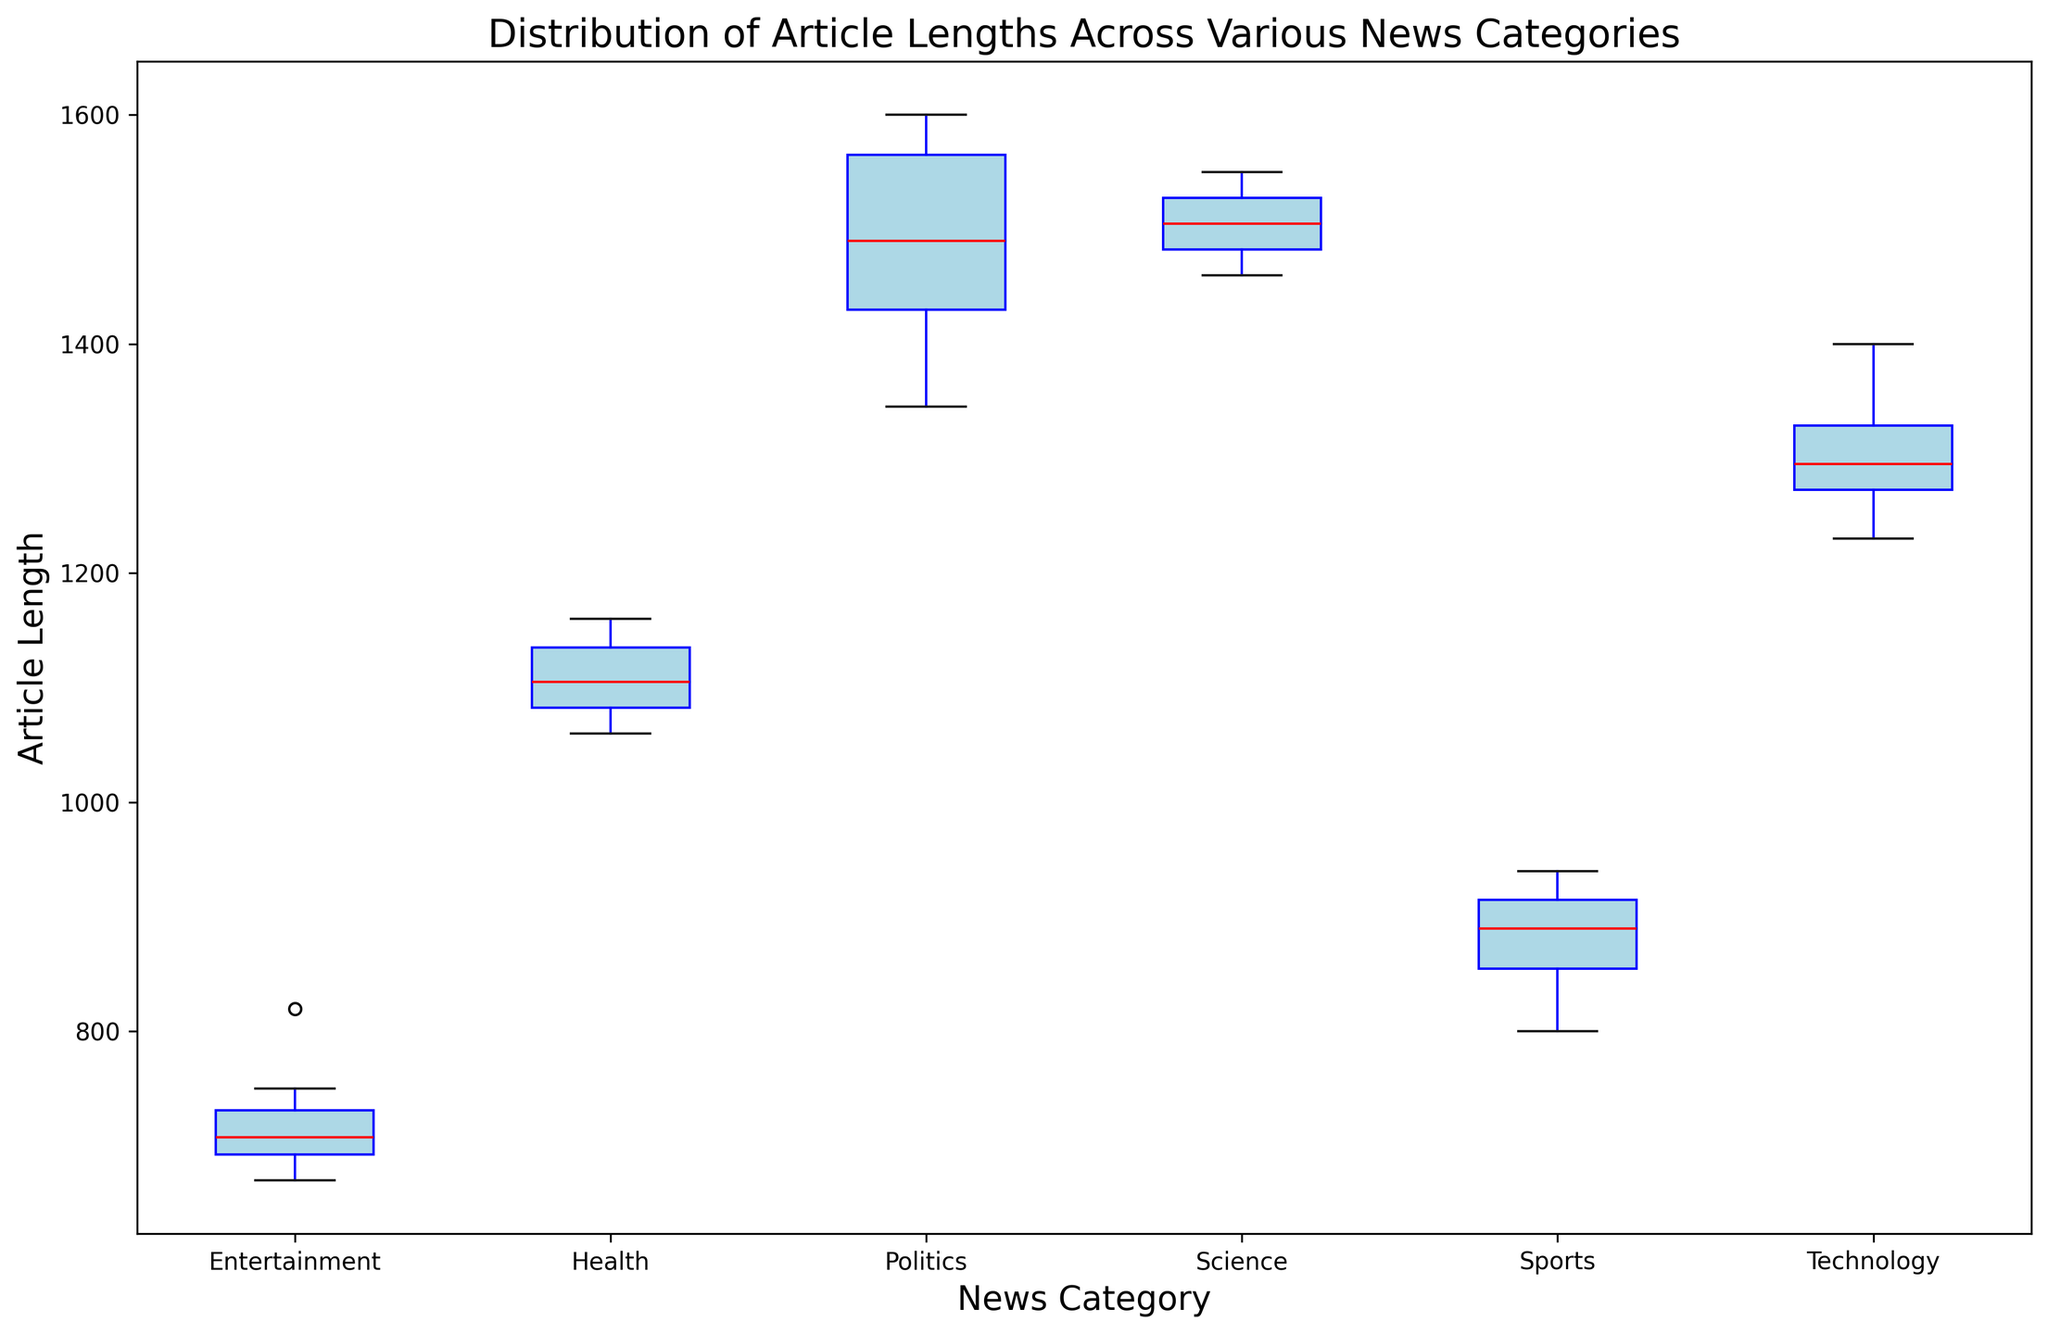What's the median article length for the 'Politics' category? The red line inside the box of the 'Politics' category represents the median. By looking at the red line within the 'Politics' box, we can determine the median length.
Answer: 1500 Which category has the smallest interquartile range (IQR) for article lengths? The IQR is represented by the width of the box in each category. By visually comparing the widths of the boxes, we can identify which one is the smallest.
Answer: Entertainment What is the range of article lengths for the 'Science' category? The range is determined by subtracting the smallest value (lower whisker) from the largest value (upper whisker) in the 'Science' box plot.
Answer: 90 How do the median article lengths of 'Technology' and 'Health' categories compare? By looking at the red median lines inside the 'Technology' and 'Health' category boxes, we can compare their positions.
Answer: Technology has a higher median than Health Which category has the highest variability in article lengths? Variability can be inferred from the length of the whiskers and the presence of outliers. The category with the longest whiskers or many outliers indicates higher variability.
Answer: Politics Do any categories have outliers and if so, which ones? Outliers are indicated by red circle markers outside the whiskers. By looking for these markers, we can determine which categories have them.
Answer: Politics and Sports Which category has the shortest median article length? The shortest median is indicated by the lowest red line inside any of the boxes. By comparing all the red lines, we can identify the lowest.
Answer: Entertainment Is there any overlap in the article length ranges between the 'Sports' and 'Entertainment' categories? Overlap can be determined by comparing the whiskers (minimum and maximum values) of both categories. If the ranges intersect, there is overlap.
Answer: Yes What is the difference between the upper quartile of 'Technology' and the lower quartile of 'Politics'? The upper quartile is represented by the top edge of the box, and the lower quartile is the bottom edge. By identifying these values for 'Technology' and 'Politics', we can calculate their difference.
Answer: 120 How does the interquartile range (IQR) of 'Health' compare to that of 'Science'? IQR is represented by the size of the box. By visually comparing the width of the boxes in 'Health' and 'Science', we can describe the difference in their IQRs.
Answer: Health has a larger IQR than Science 